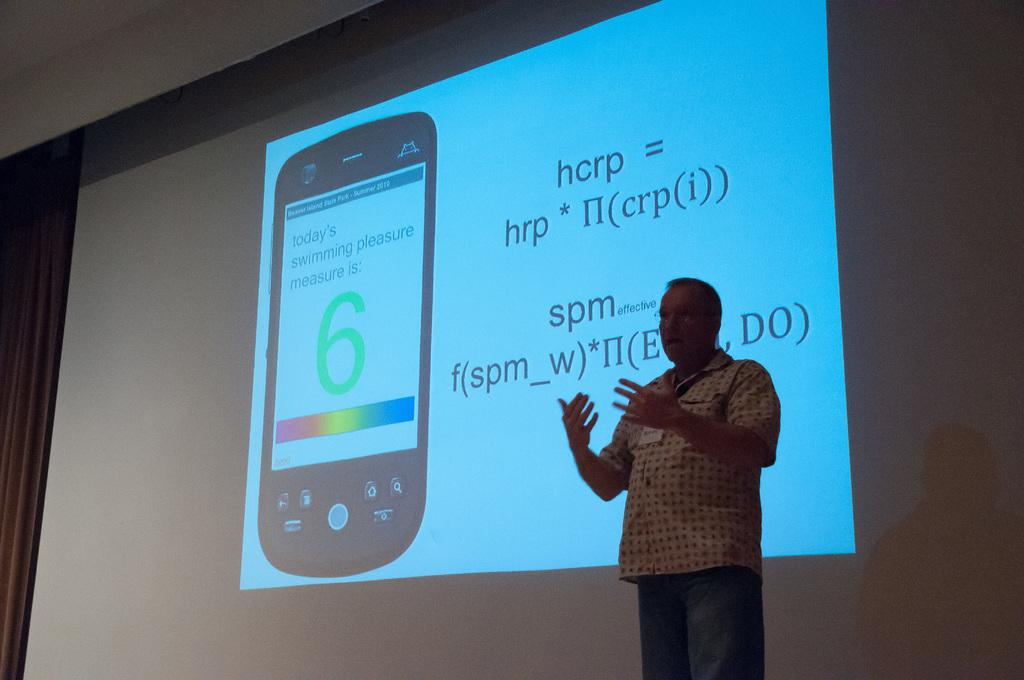Provide a one-sentence caption for the provided image. A man is giving a presentation in front of a projector screen with an equation for hcrp. 